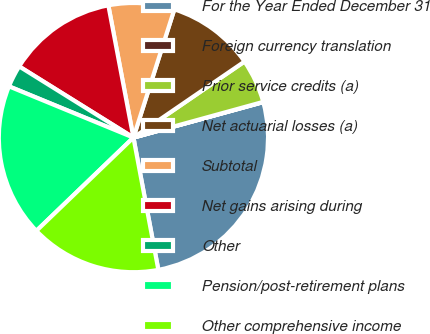Convert chart to OTSL. <chart><loc_0><loc_0><loc_500><loc_500><pie_chart><fcel>For the Year Ended December 31<fcel>Foreign currency translation<fcel>Prior service credits (a)<fcel>Net actuarial losses (a)<fcel>Subtotal<fcel>Net gains arising during<fcel>Other<fcel>Pension/post-retirement plans<fcel>Other comprehensive income<nl><fcel>26.28%<fcel>0.03%<fcel>5.28%<fcel>10.53%<fcel>7.9%<fcel>13.15%<fcel>2.65%<fcel>18.4%<fcel>15.78%<nl></chart> 